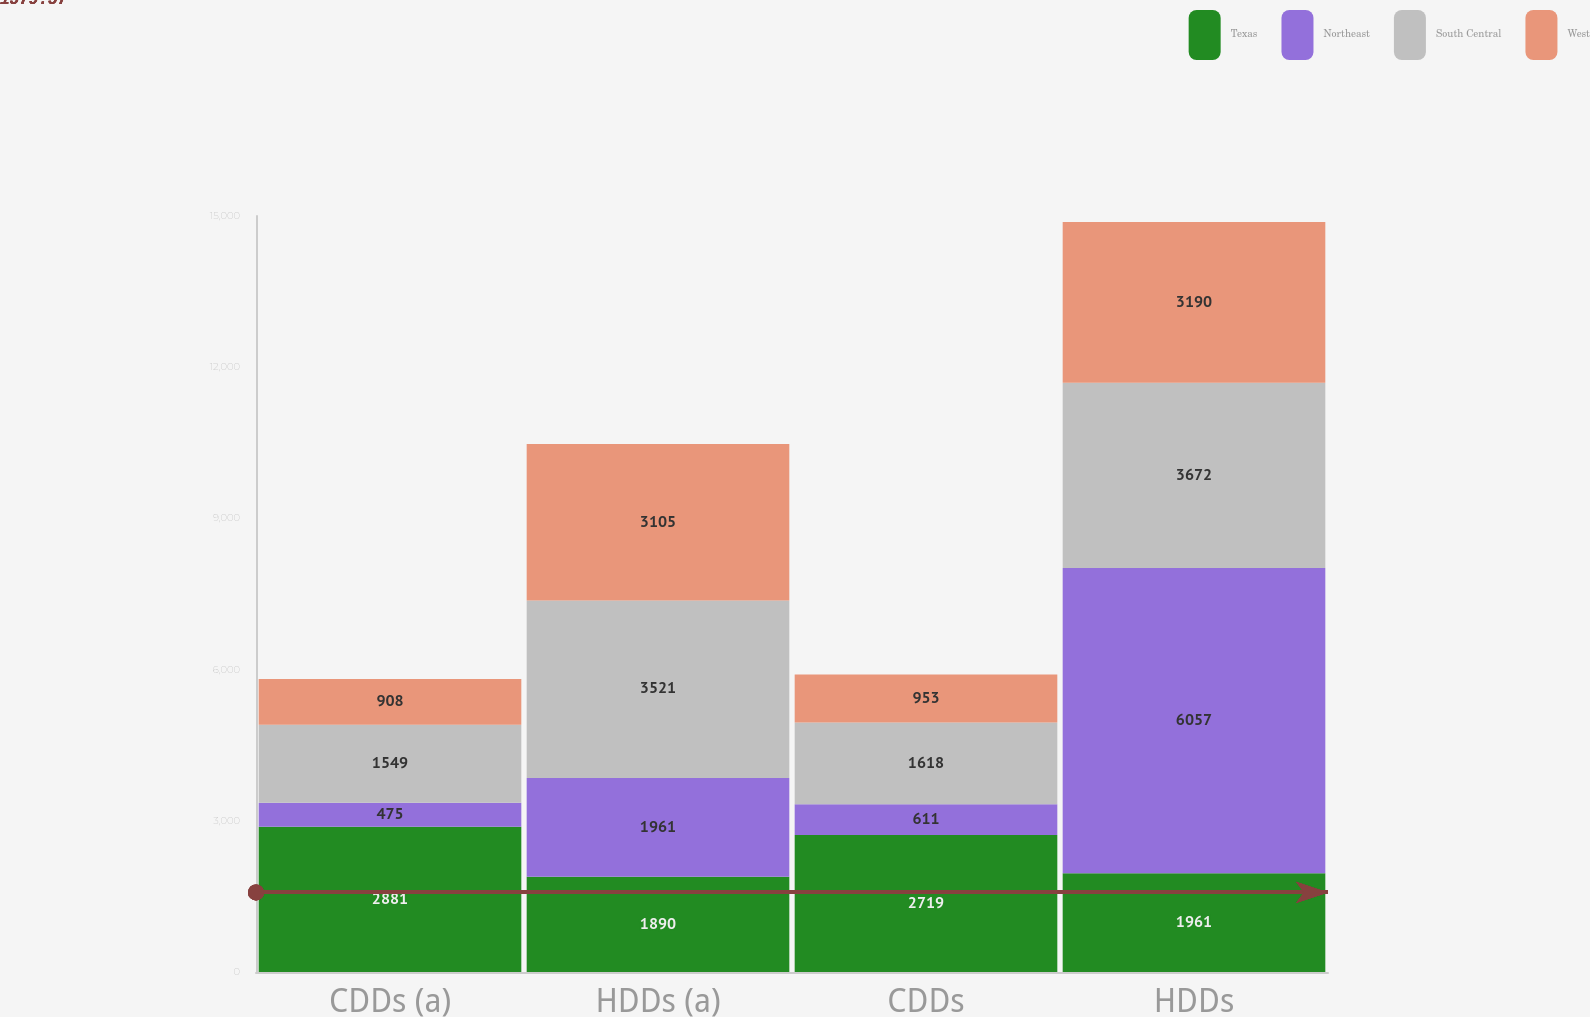<chart> <loc_0><loc_0><loc_500><loc_500><stacked_bar_chart><ecel><fcel>CDDs (a)<fcel>HDDs (a)<fcel>CDDs<fcel>HDDs<nl><fcel>Texas<fcel>2881<fcel>1890<fcel>2719<fcel>1961<nl><fcel>Northeast<fcel>475<fcel>1961<fcel>611<fcel>6057<nl><fcel>South Central<fcel>1549<fcel>3521<fcel>1618<fcel>3672<nl><fcel>West<fcel>908<fcel>3105<fcel>953<fcel>3190<nl></chart> 